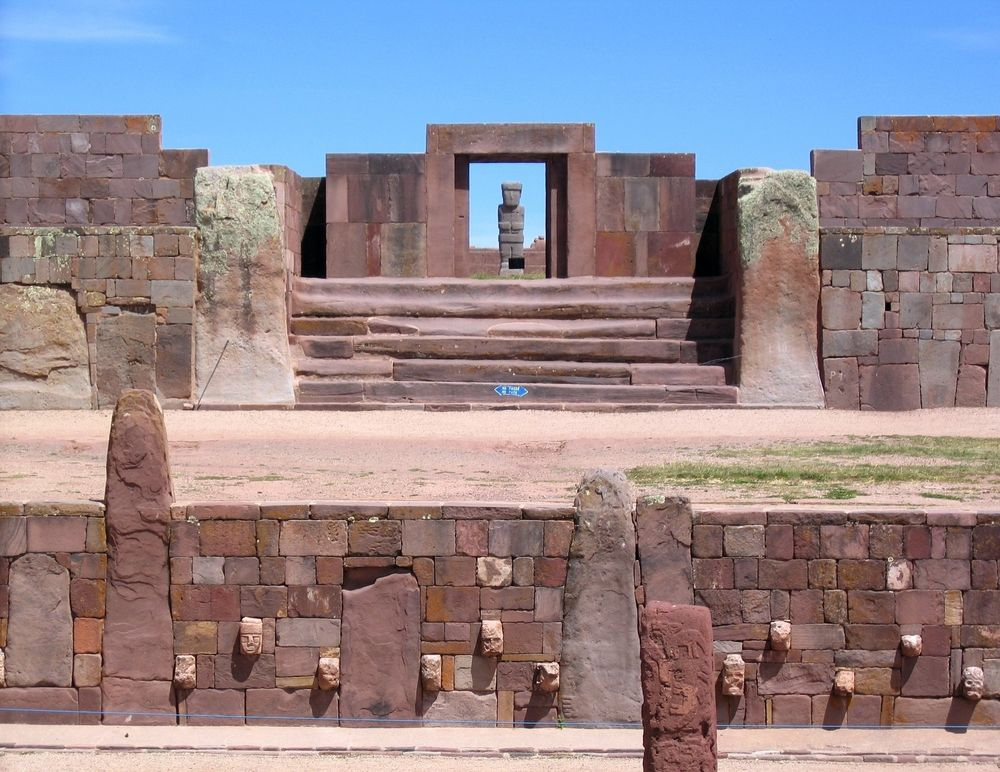Considering the climate and geography of the region, what challenges would the Tiwanaku builders have faced? The Tiwanaku builders would have faced numerous challenges due to the climate and geography of the region. Situated at a high altitude on the Andean plateau, the thin air and cooler temperatures would have made physical labor more demanding and exhausting. The area is also subject to harsh weather conditions, including intense solar radiation during the day and freezing temperatures at night, posing additional difficulties for both workers and the longevity of their structures. Seasonal variations, such as the rainy season, could have caused complications related to water management, requiring sophisticated drainage systems to prevent flooding and erosion. Additionally, the transportation of heavy stone materials from distant quarries across challenging terrains would have demanded ingenious logistics and the use of sophisticated tools and techniques. Despite these adversities, the Tiwanaku civilization demonstrated remarkable ingenuity and resilience, utilizing their deep understanding of their environment to create enduring marvels of architecture and engineering. Imagine discovering a hidden chamber within this structure. What secrets might it hold? Discovering a hidden chamber within the Tiwanaku structure could unveil secrets long buried by time. This secretive space, untouched for centuries, would likely contain an array of artifacts that shine light on the daily lives, religious practices, and advanced knowledge of the Tiwanaku people. One might find intricately crafted pottery, gold ornaments, and ceremonial objects, each telling a story of cultural importance. Ancient scrolls or stone tablets etched with hieroglyphs might be discovered, revealing wisdom on everything from astronomy to medicine. The chamber's walls could be adorned with vibrant murals depicting mythological tales and historical events, providing unprecedented insights into the civilization's worldview. Additionally, tools used in construction and art could highlight the technological prowess and artistic sensibilities of the Tiwanaku artisans. More fascinatingly, one might unearth a subterranean spring revered as a sacred source of life-sustaining water, emphasizing the site’s spiritual significance. The hidden chamber would be a treasure trove of historical and cultural revelations, offering a rare, tangible connection to a profoundly influential yet mysterious civilization. 